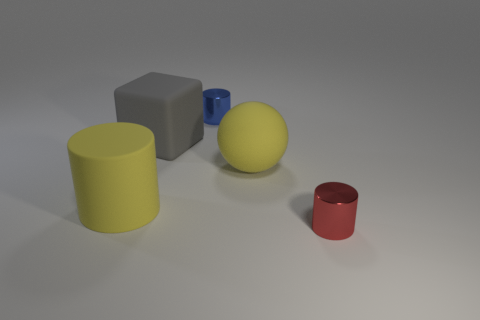Add 3 brown rubber cylinders. How many objects exist? 8 Subtract all spheres. How many objects are left? 4 Subtract all yellow balls. Subtract all big gray matte cubes. How many objects are left? 3 Add 4 big yellow objects. How many big yellow objects are left? 6 Add 5 tiny metallic objects. How many tiny metallic objects exist? 7 Subtract 0 gray cylinders. How many objects are left? 5 